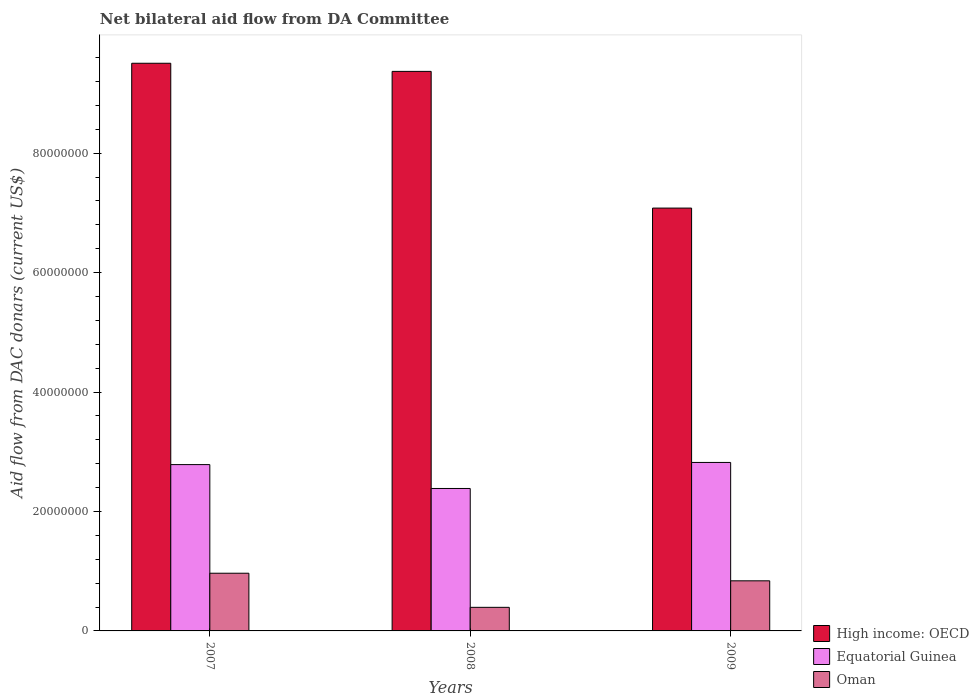Are the number of bars per tick equal to the number of legend labels?
Provide a succinct answer. Yes. How many bars are there on the 1st tick from the right?
Provide a succinct answer. 3. What is the aid flow in in Oman in 2008?
Offer a very short reply. 3.95e+06. Across all years, what is the maximum aid flow in in High income: OECD?
Offer a very short reply. 9.50e+07. Across all years, what is the minimum aid flow in in High income: OECD?
Your answer should be very brief. 7.08e+07. In which year was the aid flow in in High income: OECD maximum?
Keep it short and to the point. 2007. What is the total aid flow in in High income: OECD in the graph?
Keep it short and to the point. 2.60e+08. What is the difference between the aid flow in in High income: OECD in 2008 and that in 2009?
Keep it short and to the point. 2.29e+07. What is the difference between the aid flow in in Oman in 2007 and the aid flow in in Equatorial Guinea in 2008?
Your answer should be very brief. -1.42e+07. What is the average aid flow in in Oman per year?
Keep it short and to the point. 7.33e+06. In the year 2009, what is the difference between the aid flow in in Oman and aid flow in in High income: OECD?
Your response must be concise. -6.24e+07. What is the ratio of the aid flow in in Equatorial Guinea in 2008 to that in 2009?
Ensure brevity in your answer.  0.85. Is the difference between the aid flow in in Oman in 2008 and 2009 greater than the difference between the aid flow in in High income: OECD in 2008 and 2009?
Provide a succinct answer. No. What is the difference between the highest and the second highest aid flow in in High income: OECD?
Your response must be concise. 1.36e+06. What is the difference between the highest and the lowest aid flow in in Oman?
Give a very brief answer. 5.71e+06. What does the 2nd bar from the left in 2009 represents?
Provide a short and direct response. Equatorial Guinea. What does the 1st bar from the right in 2009 represents?
Provide a short and direct response. Oman. Is it the case that in every year, the sum of the aid flow in in Oman and aid flow in in Equatorial Guinea is greater than the aid flow in in High income: OECD?
Ensure brevity in your answer.  No. Where does the legend appear in the graph?
Keep it short and to the point. Bottom right. How many legend labels are there?
Make the answer very short. 3. How are the legend labels stacked?
Your answer should be compact. Vertical. What is the title of the graph?
Your answer should be very brief. Net bilateral aid flow from DA Committee. Does "Finland" appear as one of the legend labels in the graph?
Your answer should be compact. No. What is the label or title of the Y-axis?
Give a very brief answer. Aid flow from DAC donars (current US$). What is the Aid flow from DAC donars (current US$) in High income: OECD in 2007?
Ensure brevity in your answer.  9.50e+07. What is the Aid flow from DAC donars (current US$) in Equatorial Guinea in 2007?
Ensure brevity in your answer.  2.78e+07. What is the Aid flow from DAC donars (current US$) of Oman in 2007?
Your answer should be very brief. 9.66e+06. What is the Aid flow from DAC donars (current US$) in High income: OECD in 2008?
Provide a short and direct response. 9.37e+07. What is the Aid flow from DAC donars (current US$) of Equatorial Guinea in 2008?
Provide a short and direct response. 2.38e+07. What is the Aid flow from DAC donars (current US$) of Oman in 2008?
Provide a short and direct response. 3.95e+06. What is the Aid flow from DAC donars (current US$) of High income: OECD in 2009?
Give a very brief answer. 7.08e+07. What is the Aid flow from DAC donars (current US$) in Equatorial Guinea in 2009?
Ensure brevity in your answer.  2.82e+07. What is the Aid flow from DAC donars (current US$) of Oman in 2009?
Offer a terse response. 8.39e+06. Across all years, what is the maximum Aid flow from DAC donars (current US$) in High income: OECD?
Ensure brevity in your answer.  9.50e+07. Across all years, what is the maximum Aid flow from DAC donars (current US$) in Equatorial Guinea?
Your answer should be compact. 2.82e+07. Across all years, what is the maximum Aid flow from DAC donars (current US$) of Oman?
Give a very brief answer. 9.66e+06. Across all years, what is the minimum Aid flow from DAC donars (current US$) in High income: OECD?
Provide a succinct answer. 7.08e+07. Across all years, what is the minimum Aid flow from DAC donars (current US$) of Equatorial Guinea?
Make the answer very short. 2.38e+07. Across all years, what is the minimum Aid flow from DAC donars (current US$) in Oman?
Provide a succinct answer. 3.95e+06. What is the total Aid flow from DAC donars (current US$) of High income: OECD in the graph?
Ensure brevity in your answer.  2.60e+08. What is the total Aid flow from DAC donars (current US$) of Equatorial Guinea in the graph?
Provide a succinct answer. 7.99e+07. What is the total Aid flow from DAC donars (current US$) in Oman in the graph?
Give a very brief answer. 2.20e+07. What is the difference between the Aid flow from DAC donars (current US$) of High income: OECD in 2007 and that in 2008?
Keep it short and to the point. 1.36e+06. What is the difference between the Aid flow from DAC donars (current US$) in Oman in 2007 and that in 2008?
Make the answer very short. 5.71e+06. What is the difference between the Aid flow from DAC donars (current US$) of High income: OECD in 2007 and that in 2009?
Give a very brief answer. 2.42e+07. What is the difference between the Aid flow from DAC donars (current US$) of Equatorial Guinea in 2007 and that in 2009?
Offer a terse response. -3.60e+05. What is the difference between the Aid flow from DAC donars (current US$) in Oman in 2007 and that in 2009?
Offer a terse response. 1.27e+06. What is the difference between the Aid flow from DAC donars (current US$) in High income: OECD in 2008 and that in 2009?
Offer a terse response. 2.29e+07. What is the difference between the Aid flow from DAC donars (current US$) in Equatorial Guinea in 2008 and that in 2009?
Your response must be concise. -4.36e+06. What is the difference between the Aid flow from DAC donars (current US$) in Oman in 2008 and that in 2009?
Your answer should be compact. -4.44e+06. What is the difference between the Aid flow from DAC donars (current US$) in High income: OECD in 2007 and the Aid flow from DAC donars (current US$) in Equatorial Guinea in 2008?
Offer a very short reply. 7.12e+07. What is the difference between the Aid flow from DAC donars (current US$) in High income: OECD in 2007 and the Aid flow from DAC donars (current US$) in Oman in 2008?
Your answer should be compact. 9.11e+07. What is the difference between the Aid flow from DAC donars (current US$) in Equatorial Guinea in 2007 and the Aid flow from DAC donars (current US$) in Oman in 2008?
Keep it short and to the point. 2.39e+07. What is the difference between the Aid flow from DAC donars (current US$) of High income: OECD in 2007 and the Aid flow from DAC donars (current US$) of Equatorial Guinea in 2009?
Offer a terse response. 6.68e+07. What is the difference between the Aid flow from DAC donars (current US$) of High income: OECD in 2007 and the Aid flow from DAC donars (current US$) of Oman in 2009?
Provide a short and direct response. 8.67e+07. What is the difference between the Aid flow from DAC donars (current US$) in Equatorial Guinea in 2007 and the Aid flow from DAC donars (current US$) in Oman in 2009?
Ensure brevity in your answer.  1.95e+07. What is the difference between the Aid flow from DAC donars (current US$) in High income: OECD in 2008 and the Aid flow from DAC donars (current US$) in Equatorial Guinea in 2009?
Make the answer very short. 6.55e+07. What is the difference between the Aid flow from DAC donars (current US$) of High income: OECD in 2008 and the Aid flow from DAC donars (current US$) of Oman in 2009?
Provide a succinct answer. 8.53e+07. What is the difference between the Aid flow from DAC donars (current US$) of Equatorial Guinea in 2008 and the Aid flow from DAC donars (current US$) of Oman in 2009?
Your answer should be very brief. 1.55e+07. What is the average Aid flow from DAC donars (current US$) of High income: OECD per year?
Offer a very short reply. 8.65e+07. What is the average Aid flow from DAC donars (current US$) of Equatorial Guinea per year?
Your response must be concise. 2.66e+07. What is the average Aid flow from DAC donars (current US$) of Oman per year?
Offer a terse response. 7.33e+06. In the year 2007, what is the difference between the Aid flow from DAC donars (current US$) of High income: OECD and Aid flow from DAC donars (current US$) of Equatorial Guinea?
Offer a very short reply. 6.72e+07. In the year 2007, what is the difference between the Aid flow from DAC donars (current US$) in High income: OECD and Aid flow from DAC donars (current US$) in Oman?
Ensure brevity in your answer.  8.54e+07. In the year 2007, what is the difference between the Aid flow from DAC donars (current US$) of Equatorial Guinea and Aid flow from DAC donars (current US$) of Oman?
Your answer should be very brief. 1.82e+07. In the year 2008, what is the difference between the Aid flow from DAC donars (current US$) in High income: OECD and Aid flow from DAC donars (current US$) in Equatorial Guinea?
Make the answer very short. 6.98e+07. In the year 2008, what is the difference between the Aid flow from DAC donars (current US$) in High income: OECD and Aid flow from DAC donars (current US$) in Oman?
Your response must be concise. 8.97e+07. In the year 2008, what is the difference between the Aid flow from DAC donars (current US$) of Equatorial Guinea and Aid flow from DAC donars (current US$) of Oman?
Provide a short and direct response. 1.99e+07. In the year 2009, what is the difference between the Aid flow from DAC donars (current US$) of High income: OECD and Aid flow from DAC donars (current US$) of Equatorial Guinea?
Provide a succinct answer. 4.26e+07. In the year 2009, what is the difference between the Aid flow from DAC donars (current US$) in High income: OECD and Aid flow from DAC donars (current US$) in Oman?
Provide a succinct answer. 6.24e+07. In the year 2009, what is the difference between the Aid flow from DAC donars (current US$) in Equatorial Guinea and Aid flow from DAC donars (current US$) in Oman?
Provide a short and direct response. 1.98e+07. What is the ratio of the Aid flow from DAC donars (current US$) in High income: OECD in 2007 to that in 2008?
Provide a succinct answer. 1.01. What is the ratio of the Aid flow from DAC donars (current US$) in Equatorial Guinea in 2007 to that in 2008?
Offer a terse response. 1.17. What is the ratio of the Aid flow from DAC donars (current US$) of Oman in 2007 to that in 2008?
Make the answer very short. 2.45. What is the ratio of the Aid flow from DAC donars (current US$) in High income: OECD in 2007 to that in 2009?
Make the answer very short. 1.34. What is the ratio of the Aid flow from DAC donars (current US$) of Equatorial Guinea in 2007 to that in 2009?
Make the answer very short. 0.99. What is the ratio of the Aid flow from DAC donars (current US$) in Oman in 2007 to that in 2009?
Provide a succinct answer. 1.15. What is the ratio of the Aid flow from DAC donars (current US$) in High income: OECD in 2008 to that in 2009?
Your answer should be compact. 1.32. What is the ratio of the Aid flow from DAC donars (current US$) of Equatorial Guinea in 2008 to that in 2009?
Your response must be concise. 0.85. What is the ratio of the Aid flow from DAC donars (current US$) of Oman in 2008 to that in 2009?
Your response must be concise. 0.47. What is the difference between the highest and the second highest Aid flow from DAC donars (current US$) of High income: OECD?
Ensure brevity in your answer.  1.36e+06. What is the difference between the highest and the second highest Aid flow from DAC donars (current US$) in Oman?
Your answer should be compact. 1.27e+06. What is the difference between the highest and the lowest Aid flow from DAC donars (current US$) in High income: OECD?
Ensure brevity in your answer.  2.42e+07. What is the difference between the highest and the lowest Aid flow from DAC donars (current US$) in Equatorial Guinea?
Offer a very short reply. 4.36e+06. What is the difference between the highest and the lowest Aid flow from DAC donars (current US$) of Oman?
Offer a terse response. 5.71e+06. 